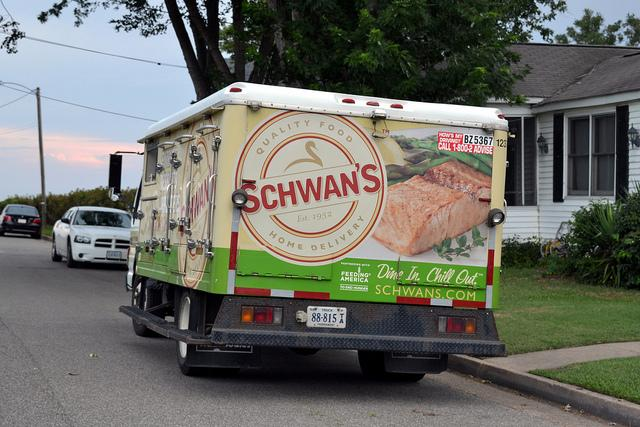How does the it feel inside the back of the truck?

Choices:
A) muggy
B) warm
C) cold
D) scorching cold 